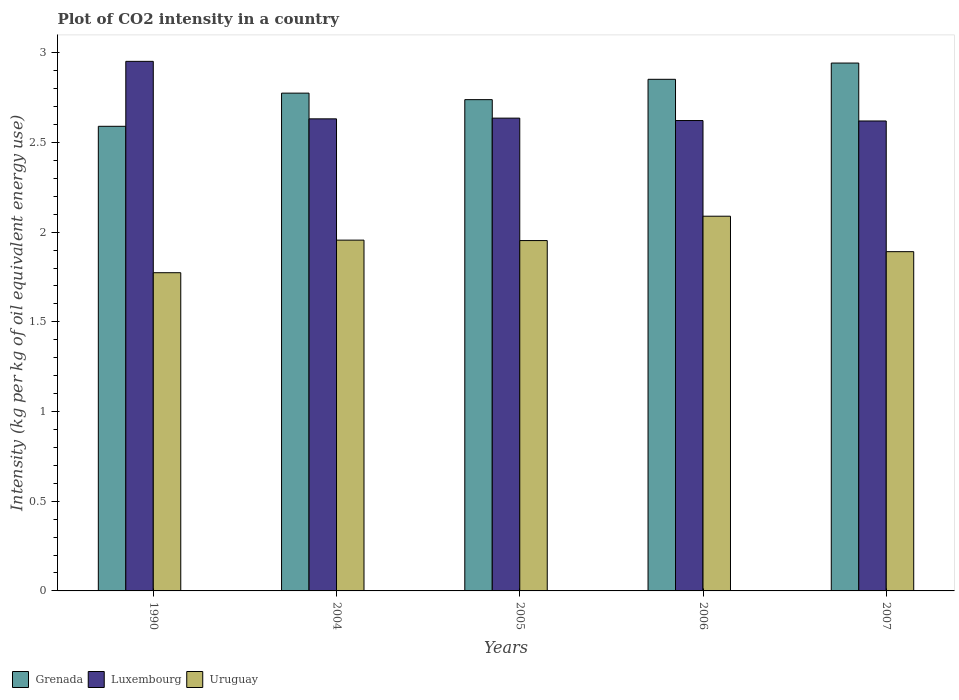How many groups of bars are there?
Offer a very short reply. 5. Are the number of bars on each tick of the X-axis equal?
Keep it short and to the point. Yes. How many bars are there on the 2nd tick from the left?
Provide a succinct answer. 3. How many bars are there on the 4th tick from the right?
Offer a terse response. 3. What is the label of the 1st group of bars from the left?
Make the answer very short. 1990. In how many cases, is the number of bars for a given year not equal to the number of legend labels?
Provide a short and direct response. 0. What is the CO2 intensity in in Uruguay in 2007?
Offer a terse response. 1.89. Across all years, what is the maximum CO2 intensity in in Uruguay?
Your response must be concise. 2.09. Across all years, what is the minimum CO2 intensity in in Luxembourg?
Ensure brevity in your answer.  2.62. In which year was the CO2 intensity in in Uruguay minimum?
Offer a terse response. 1990. What is the total CO2 intensity in in Grenada in the graph?
Give a very brief answer. 13.9. What is the difference between the CO2 intensity in in Grenada in 2004 and that in 2007?
Give a very brief answer. -0.17. What is the difference between the CO2 intensity in in Luxembourg in 2007 and the CO2 intensity in in Grenada in 2005?
Your answer should be compact. -0.12. What is the average CO2 intensity in in Uruguay per year?
Provide a succinct answer. 1.93. In the year 1990, what is the difference between the CO2 intensity in in Luxembourg and CO2 intensity in in Grenada?
Offer a terse response. 0.36. What is the ratio of the CO2 intensity in in Luxembourg in 2005 to that in 2007?
Make the answer very short. 1.01. Is the difference between the CO2 intensity in in Luxembourg in 1990 and 2006 greater than the difference between the CO2 intensity in in Grenada in 1990 and 2006?
Your answer should be compact. Yes. What is the difference between the highest and the second highest CO2 intensity in in Luxembourg?
Give a very brief answer. 0.32. What is the difference between the highest and the lowest CO2 intensity in in Uruguay?
Your answer should be compact. 0.31. Is the sum of the CO2 intensity in in Grenada in 1990 and 2007 greater than the maximum CO2 intensity in in Uruguay across all years?
Give a very brief answer. Yes. What does the 1st bar from the left in 2007 represents?
Give a very brief answer. Grenada. What does the 1st bar from the right in 2005 represents?
Offer a very short reply. Uruguay. Are all the bars in the graph horizontal?
Give a very brief answer. No. How many years are there in the graph?
Your answer should be very brief. 5. What is the difference between two consecutive major ticks on the Y-axis?
Keep it short and to the point. 0.5. Are the values on the major ticks of Y-axis written in scientific E-notation?
Your response must be concise. No. What is the title of the graph?
Provide a short and direct response. Plot of CO2 intensity in a country. What is the label or title of the Y-axis?
Provide a short and direct response. Intensity (kg per kg of oil equivalent energy use). What is the Intensity (kg per kg of oil equivalent energy use) of Grenada in 1990?
Provide a succinct answer. 2.59. What is the Intensity (kg per kg of oil equivalent energy use) in Luxembourg in 1990?
Your answer should be very brief. 2.95. What is the Intensity (kg per kg of oil equivalent energy use) in Uruguay in 1990?
Give a very brief answer. 1.77. What is the Intensity (kg per kg of oil equivalent energy use) in Grenada in 2004?
Offer a very short reply. 2.78. What is the Intensity (kg per kg of oil equivalent energy use) in Luxembourg in 2004?
Offer a terse response. 2.63. What is the Intensity (kg per kg of oil equivalent energy use) of Uruguay in 2004?
Your answer should be compact. 1.96. What is the Intensity (kg per kg of oil equivalent energy use) in Grenada in 2005?
Offer a terse response. 2.74. What is the Intensity (kg per kg of oil equivalent energy use) of Luxembourg in 2005?
Keep it short and to the point. 2.64. What is the Intensity (kg per kg of oil equivalent energy use) in Uruguay in 2005?
Your answer should be compact. 1.95. What is the Intensity (kg per kg of oil equivalent energy use) in Grenada in 2006?
Make the answer very short. 2.85. What is the Intensity (kg per kg of oil equivalent energy use) in Luxembourg in 2006?
Offer a terse response. 2.62. What is the Intensity (kg per kg of oil equivalent energy use) in Uruguay in 2006?
Provide a short and direct response. 2.09. What is the Intensity (kg per kg of oil equivalent energy use) in Grenada in 2007?
Provide a succinct answer. 2.94. What is the Intensity (kg per kg of oil equivalent energy use) in Luxembourg in 2007?
Provide a succinct answer. 2.62. What is the Intensity (kg per kg of oil equivalent energy use) in Uruguay in 2007?
Keep it short and to the point. 1.89. Across all years, what is the maximum Intensity (kg per kg of oil equivalent energy use) of Grenada?
Your answer should be very brief. 2.94. Across all years, what is the maximum Intensity (kg per kg of oil equivalent energy use) of Luxembourg?
Provide a succinct answer. 2.95. Across all years, what is the maximum Intensity (kg per kg of oil equivalent energy use) in Uruguay?
Give a very brief answer. 2.09. Across all years, what is the minimum Intensity (kg per kg of oil equivalent energy use) of Grenada?
Provide a succinct answer. 2.59. Across all years, what is the minimum Intensity (kg per kg of oil equivalent energy use) of Luxembourg?
Provide a short and direct response. 2.62. Across all years, what is the minimum Intensity (kg per kg of oil equivalent energy use) of Uruguay?
Provide a short and direct response. 1.77. What is the total Intensity (kg per kg of oil equivalent energy use) of Grenada in the graph?
Give a very brief answer. 13.9. What is the total Intensity (kg per kg of oil equivalent energy use) of Luxembourg in the graph?
Make the answer very short. 13.46. What is the total Intensity (kg per kg of oil equivalent energy use) of Uruguay in the graph?
Your response must be concise. 9.66. What is the difference between the Intensity (kg per kg of oil equivalent energy use) in Grenada in 1990 and that in 2004?
Your response must be concise. -0.18. What is the difference between the Intensity (kg per kg of oil equivalent energy use) of Luxembourg in 1990 and that in 2004?
Keep it short and to the point. 0.32. What is the difference between the Intensity (kg per kg of oil equivalent energy use) of Uruguay in 1990 and that in 2004?
Keep it short and to the point. -0.18. What is the difference between the Intensity (kg per kg of oil equivalent energy use) of Grenada in 1990 and that in 2005?
Make the answer very short. -0.15. What is the difference between the Intensity (kg per kg of oil equivalent energy use) of Luxembourg in 1990 and that in 2005?
Make the answer very short. 0.32. What is the difference between the Intensity (kg per kg of oil equivalent energy use) in Uruguay in 1990 and that in 2005?
Provide a succinct answer. -0.18. What is the difference between the Intensity (kg per kg of oil equivalent energy use) in Grenada in 1990 and that in 2006?
Your answer should be very brief. -0.26. What is the difference between the Intensity (kg per kg of oil equivalent energy use) of Luxembourg in 1990 and that in 2006?
Provide a short and direct response. 0.33. What is the difference between the Intensity (kg per kg of oil equivalent energy use) of Uruguay in 1990 and that in 2006?
Your answer should be very brief. -0.32. What is the difference between the Intensity (kg per kg of oil equivalent energy use) in Grenada in 1990 and that in 2007?
Your answer should be very brief. -0.35. What is the difference between the Intensity (kg per kg of oil equivalent energy use) in Luxembourg in 1990 and that in 2007?
Make the answer very short. 0.33. What is the difference between the Intensity (kg per kg of oil equivalent energy use) in Uruguay in 1990 and that in 2007?
Offer a terse response. -0.12. What is the difference between the Intensity (kg per kg of oil equivalent energy use) in Grenada in 2004 and that in 2005?
Keep it short and to the point. 0.04. What is the difference between the Intensity (kg per kg of oil equivalent energy use) in Luxembourg in 2004 and that in 2005?
Your response must be concise. -0. What is the difference between the Intensity (kg per kg of oil equivalent energy use) of Uruguay in 2004 and that in 2005?
Your response must be concise. 0. What is the difference between the Intensity (kg per kg of oil equivalent energy use) of Grenada in 2004 and that in 2006?
Your answer should be compact. -0.08. What is the difference between the Intensity (kg per kg of oil equivalent energy use) in Luxembourg in 2004 and that in 2006?
Ensure brevity in your answer.  0.01. What is the difference between the Intensity (kg per kg of oil equivalent energy use) in Uruguay in 2004 and that in 2006?
Ensure brevity in your answer.  -0.13. What is the difference between the Intensity (kg per kg of oil equivalent energy use) of Grenada in 2004 and that in 2007?
Keep it short and to the point. -0.17. What is the difference between the Intensity (kg per kg of oil equivalent energy use) in Luxembourg in 2004 and that in 2007?
Offer a terse response. 0.01. What is the difference between the Intensity (kg per kg of oil equivalent energy use) in Uruguay in 2004 and that in 2007?
Provide a succinct answer. 0.06. What is the difference between the Intensity (kg per kg of oil equivalent energy use) of Grenada in 2005 and that in 2006?
Give a very brief answer. -0.11. What is the difference between the Intensity (kg per kg of oil equivalent energy use) of Luxembourg in 2005 and that in 2006?
Your answer should be very brief. 0.01. What is the difference between the Intensity (kg per kg of oil equivalent energy use) in Uruguay in 2005 and that in 2006?
Make the answer very short. -0.14. What is the difference between the Intensity (kg per kg of oil equivalent energy use) in Grenada in 2005 and that in 2007?
Your answer should be very brief. -0.2. What is the difference between the Intensity (kg per kg of oil equivalent energy use) in Luxembourg in 2005 and that in 2007?
Provide a short and direct response. 0.02. What is the difference between the Intensity (kg per kg of oil equivalent energy use) of Uruguay in 2005 and that in 2007?
Offer a very short reply. 0.06. What is the difference between the Intensity (kg per kg of oil equivalent energy use) in Grenada in 2006 and that in 2007?
Your answer should be very brief. -0.09. What is the difference between the Intensity (kg per kg of oil equivalent energy use) in Luxembourg in 2006 and that in 2007?
Provide a short and direct response. 0. What is the difference between the Intensity (kg per kg of oil equivalent energy use) of Uruguay in 2006 and that in 2007?
Keep it short and to the point. 0.2. What is the difference between the Intensity (kg per kg of oil equivalent energy use) in Grenada in 1990 and the Intensity (kg per kg of oil equivalent energy use) in Luxembourg in 2004?
Provide a succinct answer. -0.04. What is the difference between the Intensity (kg per kg of oil equivalent energy use) of Grenada in 1990 and the Intensity (kg per kg of oil equivalent energy use) of Uruguay in 2004?
Your answer should be very brief. 0.63. What is the difference between the Intensity (kg per kg of oil equivalent energy use) in Luxembourg in 1990 and the Intensity (kg per kg of oil equivalent energy use) in Uruguay in 2004?
Make the answer very short. 1. What is the difference between the Intensity (kg per kg of oil equivalent energy use) of Grenada in 1990 and the Intensity (kg per kg of oil equivalent energy use) of Luxembourg in 2005?
Provide a succinct answer. -0.05. What is the difference between the Intensity (kg per kg of oil equivalent energy use) in Grenada in 1990 and the Intensity (kg per kg of oil equivalent energy use) in Uruguay in 2005?
Keep it short and to the point. 0.64. What is the difference between the Intensity (kg per kg of oil equivalent energy use) of Grenada in 1990 and the Intensity (kg per kg of oil equivalent energy use) of Luxembourg in 2006?
Keep it short and to the point. -0.03. What is the difference between the Intensity (kg per kg of oil equivalent energy use) in Grenada in 1990 and the Intensity (kg per kg of oil equivalent energy use) in Uruguay in 2006?
Keep it short and to the point. 0.5. What is the difference between the Intensity (kg per kg of oil equivalent energy use) in Luxembourg in 1990 and the Intensity (kg per kg of oil equivalent energy use) in Uruguay in 2006?
Give a very brief answer. 0.86. What is the difference between the Intensity (kg per kg of oil equivalent energy use) of Grenada in 1990 and the Intensity (kg per kg of oil equivalent energy use) of Luxembourg in 2007?
Keep it short and to the point. -0.03. What is the difference between the Intensity (kg per kg of oil equivalent energy use) of Grenada in 1990 and the Intensity (kg per kg of oil equivalent energy use) of Uruguay in 2007?
Your answer should be very brief. 0.7. What is the difference between the Intensity (kg per kg of oil equivalent energy use) in Luxembourg in 1990 and the Intensity (kg per kg of oil equivalent energy use) in Uruguay in 2007?
Make the answer very short. 1.06. What is the difference between the Intensity (kg per kg of oil equivalent energy use) in Grenada in 2004 and the Intensity (kg per kg of oil equivalent energy use) in Luxembourg in 2005?
Ensure brevity in your answer.  0.14. What is the difference between the Intensity (kg per kg of oil equivalent energy use) in Grenada in 2004 and the Intensity (kg per kg of oil equivalent energy use) in Uruguay in 2005?
Ensure brevity in your answer.  0.82. What is the difference between the Intensity (kg per kg of oil equivalent energy use) in Luxembourg in 2004 and the Intensity (kg per kg of oil equivalent energy use) in Uruguay in 2005?
Ensure brevity in your answer.  0.68. What is the difference between the Intensity (kg per kg of oil equivalent energy use) in Grenada in 2004 and the Intensity (kg per kg of oil equivalent energy use) in Luxembourg in 2006?
Keep it short and to the point. 0.15. What is the difference between the Intensity (kg per kg of oil equivalent energy use) of Grenada in 2004 and the Intensity (kg per kg of oil equivalent energy use) of Uruguay in 2006?
Make the answer very short. 0.69. What is the difference between the Intensity (kg per kg of oil equivalent energy use) of Luxembourg in 2004 and the Intensity (kg per kg of oil equivalent energy use) of Uruguay in 2006?
Make the answer very short. 0.54. What is the difference between the Intensity (kg per kg of oil equivalent energy use) of Grenada in 2004 and the Intensity (kg per kg of oil equivalent energy use) of Luxembourg in 2007?
Your answer should be very brief. 0.16. What is the difference between the Intensity (kg per kg of oil equivalent energy use) in Grenada in 2004 and the Intensity (kg per kg of oil equivalent energy use) in Uruguay in 2007?
Keep it short and to the point. 0.88. What is the difference between the Intensity (kg per kg of oil equivalent energy use) of Luxembourg in 2004 and the Intensity (kg per kg of oil equivalent energy use) of Uruguay in 2007?
Your response must be concise. 0.74. What is the difference between the Intensity (kg per kg of oil equivalent energy use) in Grenada in 2005 and the Intensity (kg per kg of oil equivalent energy use) in Luxembourg in 2006?
Your answer should be very brief. 0.12. What is the difference between the Intensity (kg per kg of oil equivalent energy use) of Grenada in 2005 and the Intensity (kg per kg of oil equivalent energy use) of Uruguay in 2006?
Provide a short and direct response. 0.65. What is the difference between the Intensity (kg per kg of oil equivalent energy use) in Luxembourg in 2005 and the Intensity (kg per kg of oil equivalent energy use) in Uruguay in 2006?
Make the answer very short. 0.55. What is the difference between the Intensity (kg per kg of oil equivalent energy use) of Grenada in 2005 and the Intensity (kg per kg of oil equivalent energy use) of Luxembourg in 2007?
Offer a very short reply. 0.12. What is the difference between the Intensity (kg per kg of oil equivalent energy use) in Grenada in 2005 and the Intensity (kg per kg of oil equivalent energy use) in Uruguay in 2007?
Offer a very short reply. 0.85. What is the difference between the Intensity (kg per kg of oil equivalent energy use) in Luxembourg in 2005 and the Intensity (kg per kg of oil equivalent energy use) in Uruguay in 2007?
Your answer should be compact. 0.74. What is the difference between the Intensity (kg per kg of oil equivalent energy use) in Grenada in 2006 and the Intensity (kg per kg of oil equivalent energy use) in Luxembourg in 2007?
Your answer should be very brief. 0.23. What is the difference between the Intensity (kg per kg of oil equivalent energy use) in Grenada in 2006 and the Intensity (kg per kg of oil equivalent energy use) in Uruguay in 2007?
Ensure brevity in your answer.  0.96. What is the difference between the Intensity (kg per kg of oil equivalent energy use) in Luxembourg in 2006 and the Intensity (kg per kg of oil equivalent energy use) in Uruguay in 2007?
Offer a terse response. 0.73. What is the average Intensity (kg per kg of oil equivalent energy use) of Grenada per year?
Provide a short and direct response. 2.78. What is the average Intensity (kg per kg of oil equivalent energy use) of Luxembourg per year?
Ensure brevity in your answer.  2.69. What is the average Intensity (kg per kg of oil equivalent energy use) in Uruguay per year?
Make the answer very short. 1.93. In the year 1990, what is the difference between the Intensity (kg per kg of oil equivalent energy use) in Grenada and Intensity (kg per kg of oil equivalent energy use) in Luxembourg?
Provide a succinct answer. -0.36. In the year 1990, what is the difference between the Intensity (kg per kg of oil equivalent energy use) in Grenada and Intensity (kg per kg of oil equivalent energy use) in Uruguay?
Your answer should be very brief. 0.82. In the year 1990, what is the difference between the Intensity (kg per kg of oil equivalent energy use) of Luxembourg and Intensity (kg per kg of oil equivalent energy use) of Uruguay?
Provide a short and direct response. 1.18. In the year 2004, what is the difference between the Intensity (kg per kg of oil equivalent energy use) in Grenada and Intensity (kg per kg of oil equivalent energy use) in Luxembourg?
Make the answer very short. 0.14. In the year 2004, what is the difference between the Intensity (kg per kg of oil equivalent energy use) in Grenada and Intensity (kg per kg of oil equivalent energy use) in Uruguay?
Make the answer very short. 0.82. In the year 2004, what is the difference between the Intensity (kg per kg of oil equivalent energy use) in Luxembourg and Intensity (kg per kg of oil equivalent energy use) in Uruguay?
Your answer should be compact. 0.68. In the year 2005, what is the difference between the Intensity (kg per kg of oil equivalent energy use) of Grenada and Intensity (kg per kg of oil equivalent energy use) of Luxembourg?
Your answer should be compact. 0.1. In the year 2005, what is the difference between the Intensity (kg per kg of oil equivalent energy use) of Grenada and Intensity (kg per kg of oil equivalent energy use) of Uruguay?
Ensure brevity in your answer.  0.79. In the year 2005, what is the difference between the Intensity (kg per kg of oil equivalent energy use) in Luxembourg and Intensity (kg per kg of oil equivalent energy use) in Uruguay?
Make the answer very short. 0.68. In the year 2006, what is the difference between the Intensity (kg per kg of oil equivalent energy use) in Grenada and Intensity (kg per kg of oil equivalent energy use) in Luxembourg?
Ensure brevity in your answer.  0.23. In the year 2006, what is the difference between the Intensity (kg per kg of oil equivalent energy use) of Grenada and Intensity (kg per kg of oil equivalent energy use) of Uruguay?
Provide a succinct answer. 0.76. In the year 2006, what is the difference between the Intensity (kg per kg of oil equivalent energy use) in Luxembourg and Intensity (kg per kg of oil equivalent energy use) in Uruguay?
Make the answer very short. 0.53. In the year 2007, what is the difference between the Intensity (kg per kg of oil equivalent energy use) of Grenada and Intensity (kg per kg of oil equivalent energy use) of Luxembourg?
Make the answer very short. 0.32. In the year 2007, what is the difference between the Intensity (kg per kg of oil equivalent energy use) of Grenada and Intensity (kg per kg of oil equivalent energy use) of Uruguay?
Give a very brief answer. 1.05. In the year 2007, what is the difference between the Intensity (kg per kg of oil equivalent energy use) of Luxembourg and Intensity (kg per kg of oil equivalent energy use) of Uruguay?
Keep it short and to the point. 0.73. What is the ratio of the Intensity (kg per kg of oil equivalent energy use) of Luxembourg in 1990 to that in 2004?
Make the answer very short. 1.12. What is the ratio of the Intensity (kg per kg of oil equivalent energy use) of Uruguay in 1990 to that in 2004?
Your answer should be very brief. 0.91. What is the ratio of the Intensity (kg per kg of oil equivalent energy use) of Grenada in 1990 to that in 2005?
Your answer should be very brief. 0.95. What is the ratio of the Intensity (kg per kg of oil equivalent energy use) in Luxembourg in 1990 to that in 2005?
Your answer should be very brief. 1.12. What is the ratio of the Intensity (kg per kg of oil equivalent energy use) in Uruguay in 1990 to that in 2005?
Make the answer very short. 0.91. What is the ratio of the Intensity (kg per kg of oil equivalent energy use) in Grenada in 1990 to that in 2006?
Keep it short and to the point. 0.91. What is the ratio of the Intensity (kg per kg of oil equivalent energy use) of Luxembourg in 1990 to that in 2006?
Make the answer very short. 1.13. What is the ratio of the Intensity (kg per kg of oil equivalent energy use) in Uruguay in 1990 to that in 2006?
Your answer should be compact. 0.85. What is the ratio of the Intensity (kg per kg of oil equivalent energy use) in Grenada in 1990 to that in 2007?
Offer a very short reply. 0.88. What is the ratio of the Intensity (kg per kg of oil equivalent energy use) in Luxembourg in 1990 to that in 2007?
Make the answer very short. 1.13. What is the ratio of the Intensity (kg per kg of oil equivalent energy use) of Uruguay in 1990 to that in 2007?
Provide a succinct answer. 0.94. What is the ratio of the Intensity (kg per kg of oil equivalent energy use) of Grenada in 2004 to that in 2005?
Your response must be concise. 1.01. What is the ratio of the Intensity (kg per kg of oil equivalent energy use) in Luxembourg in 2004 to that in 2005?
Give a very brief answer. 1. What is the ratio of the Intensity (kg per kg of oil equivalent energy use) of Grenada in 2004 to that in 2006?
Your answer should be compact. 0.97. What is the ratio of the Intensity (kg per kg of oil equivalent energy use) of Uruguay in 2004 to that in 2006?
Keep it short and to the point. 0.94. What is the ratio of the Intensity (kg per kg of oil equivalent energy use) of Grenada in 2004 to that in 2007?
Provide a succinct answer. 0.94. What is the ratio of the Intensity (kg per kg of oil equivalent energy use) of Luxembourg in 2004 to that in 2007?
Keep it short and to the point. 1. What is the ratio of the Intensity (kg per kg of oil equivalent energy use) in Uruguay in 2004 to that in 2007?
Keep it short and to the point. 1.03. What is the ratio of the Intensity (kg per kg of oil equivalent energy use) of Grenada in 2005 to that in 2006?
Offer a terse response. 0.96. What is the ratio of the Intensity (kg per kg of oil equivalent energy use) of Uruguay in 2005 to that in 2006?
Your response must be concise. 0.94. What is the ratio of the Intensity (kg per kg of oil equivalent energy use) of Grenada in 2005 to that in 2007?
Your answer should be very brief. 0.93. What is the ratio of the Intensity (kg per kg of oil equivalent energy use) of Luxembourg in 2005 to that in 2007?
Provide a succinct answer. 1.01. What is the ratio of the Intensity (kg per kg of oil equivalent energy use) of Uruguay in 2005 to that in 2007?
Provide a short and direct response. 1.03. What is the ratio of the Intensity (kg per kg of oil equivalent energy use) of Grenada in 2006 to that in 2007?
Provide a succinct answer. 0.97. What is the ratio of the Intensity (kg per kg of oil equivalent energy use) in Uruguay in 2006 to that in 2007?
Keep it short and to the point. 1.1. What is the difference between the highest and the second highest Intensity (kg per kg of oil equivalent energy use) in Grenada?
Make the answer very short. 0.09. What is the difference between the highest and the second highest Intensity (kg per kg of oil equivalent energy use) of Luxembourg?
Keep it short and to the point. 0.32. What is the difference between the highest and the second highest Intensity (kg per kg of oil equivalent energy use) in Uruguay?
Your answer should be compact. 0.13. What is the difference between the highest and the lowest Intensity (kg per kg of oil equivalent energy use) in Grenada?
Your answer should be compact. 0.35. What is the difference between the highest and the lowest Intensity (kg per kg of oil equivalent energy use) of Luxembourg?
Ensure brevity in your answer.  0.33. What is the difference between the highest and the lowest Intensity (kg per kg of oil equivalent energy use) in Uruguay?
Your answer should be compact. 0.32. 